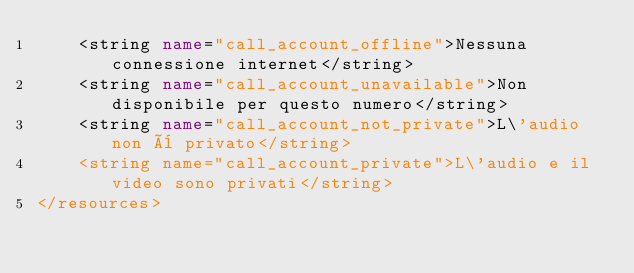Convert code to text. <code><loc_0><loc_0><loc_500><loc_500><_XML_>    <string name="call_account_offline">Nessuna connessione internet</string>
    <string name="call_account_unavailable">Non disponibile per questo numero</string>
    <string name="call_account_not_private">L\'audio non è privato</string>
    <string name="call_account_private">L\'audio e il video sono privati</string>
</resources></code> 